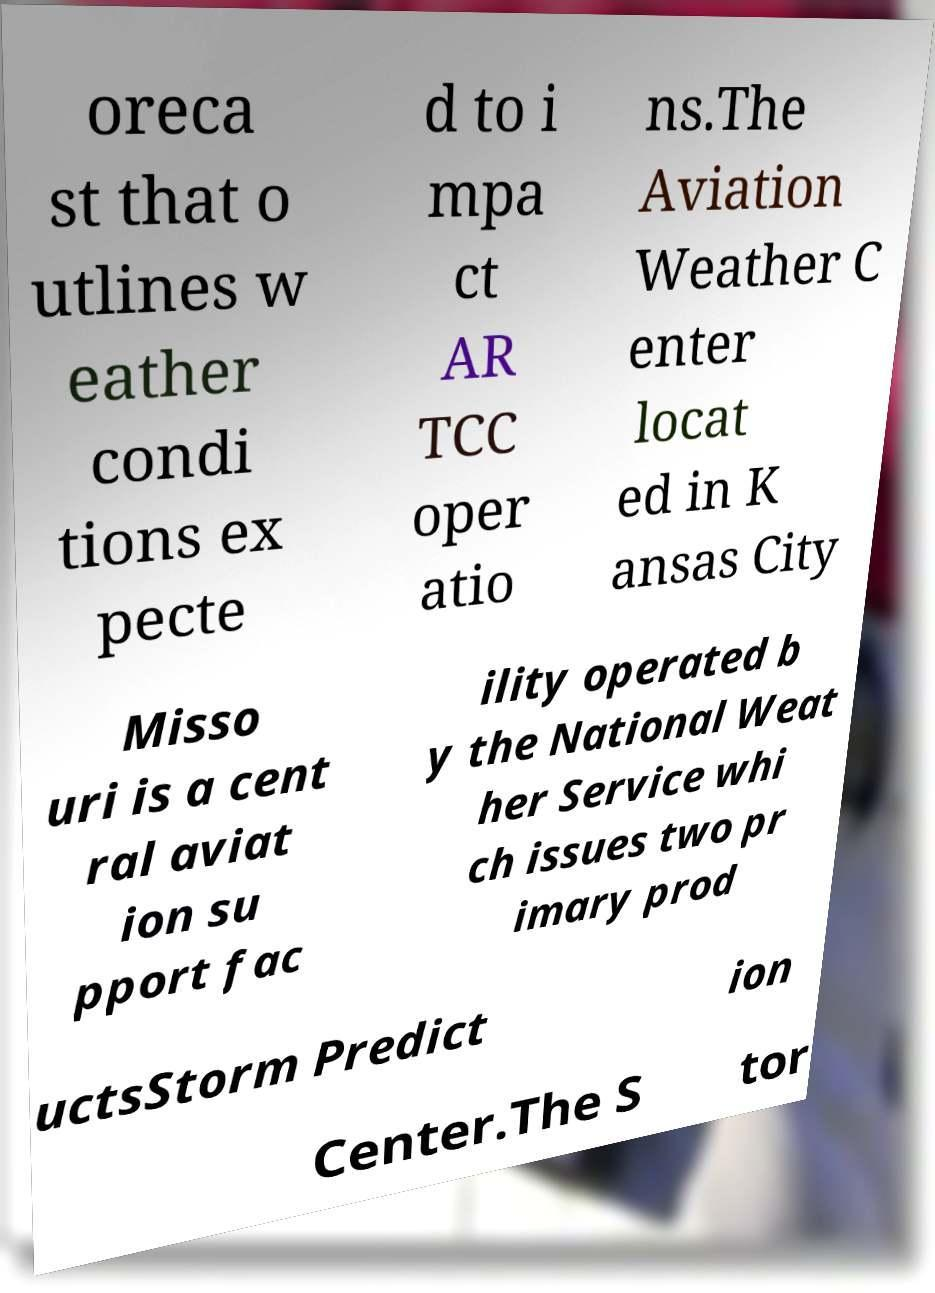Could you extract and type out the text from this image? oreca st that o utlines w eather condi tions ex pecte d to i mpa ct AR TCC oper atio ns.The Aviation Weather C enter locat ed in K ansas City Misso uri is a cent ral aviat ion su pport fac ility operated b y the National Weat her Service whi ch issues two pr imary prod uctsStorm Predict ion Center.The S tor 